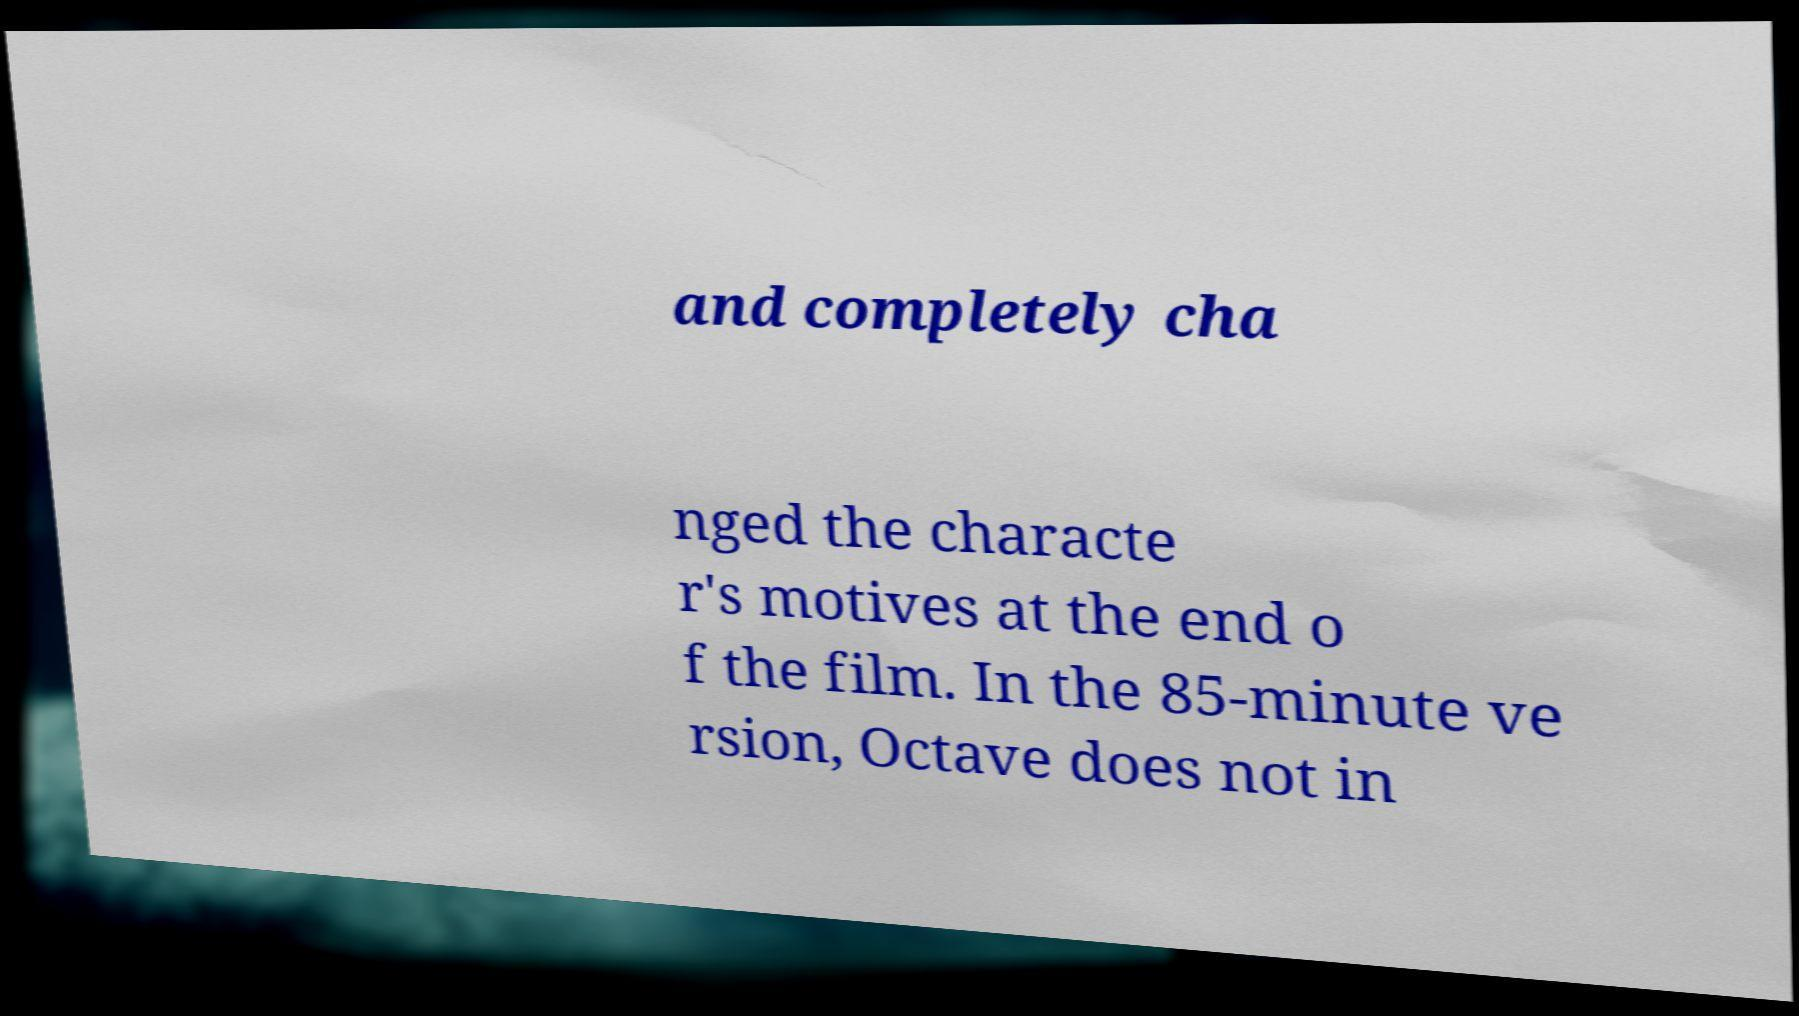Can you read and provide the text displayed in the image?This photo seems to have some interesting text. Can you extract and type it out for me? and completely cha nged the characte r's motives at the end o f the film. In the 85-minute ve rsion, Octave does not in 